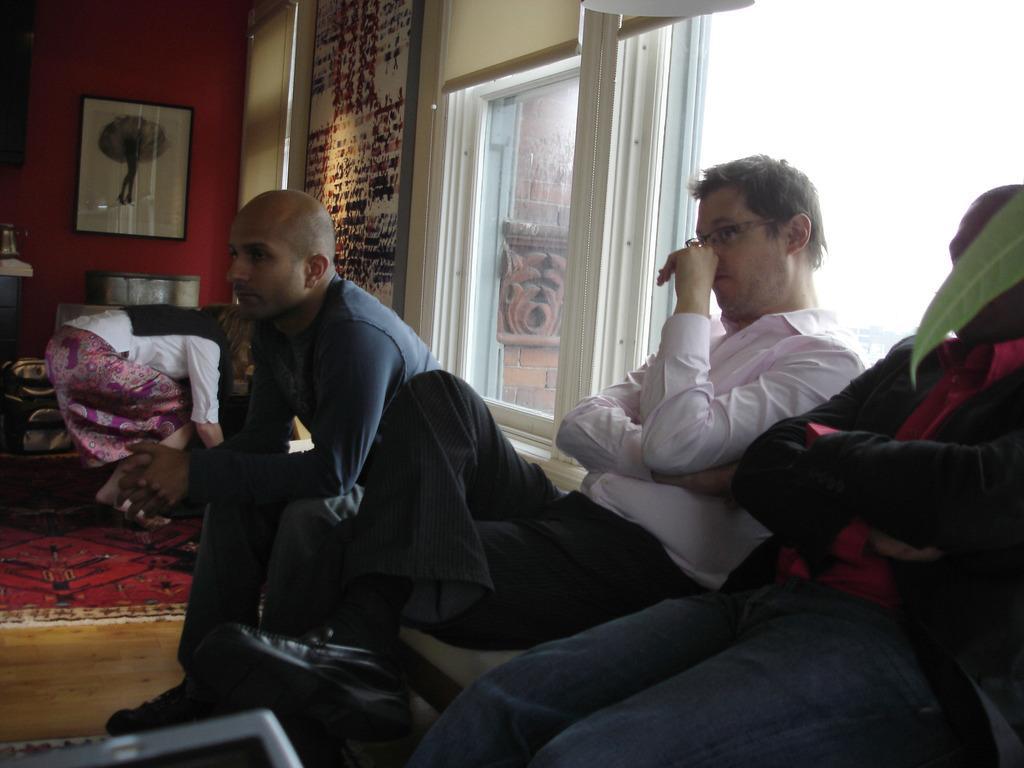How would you summarize this image in a sentence or two? The picture is taken inside a room. In the foreground of the picture we can see three persons, leaf and a table. In the middle of the picture we can see windows, frames, couch, person and other objects. Outside the window we can see wall. 